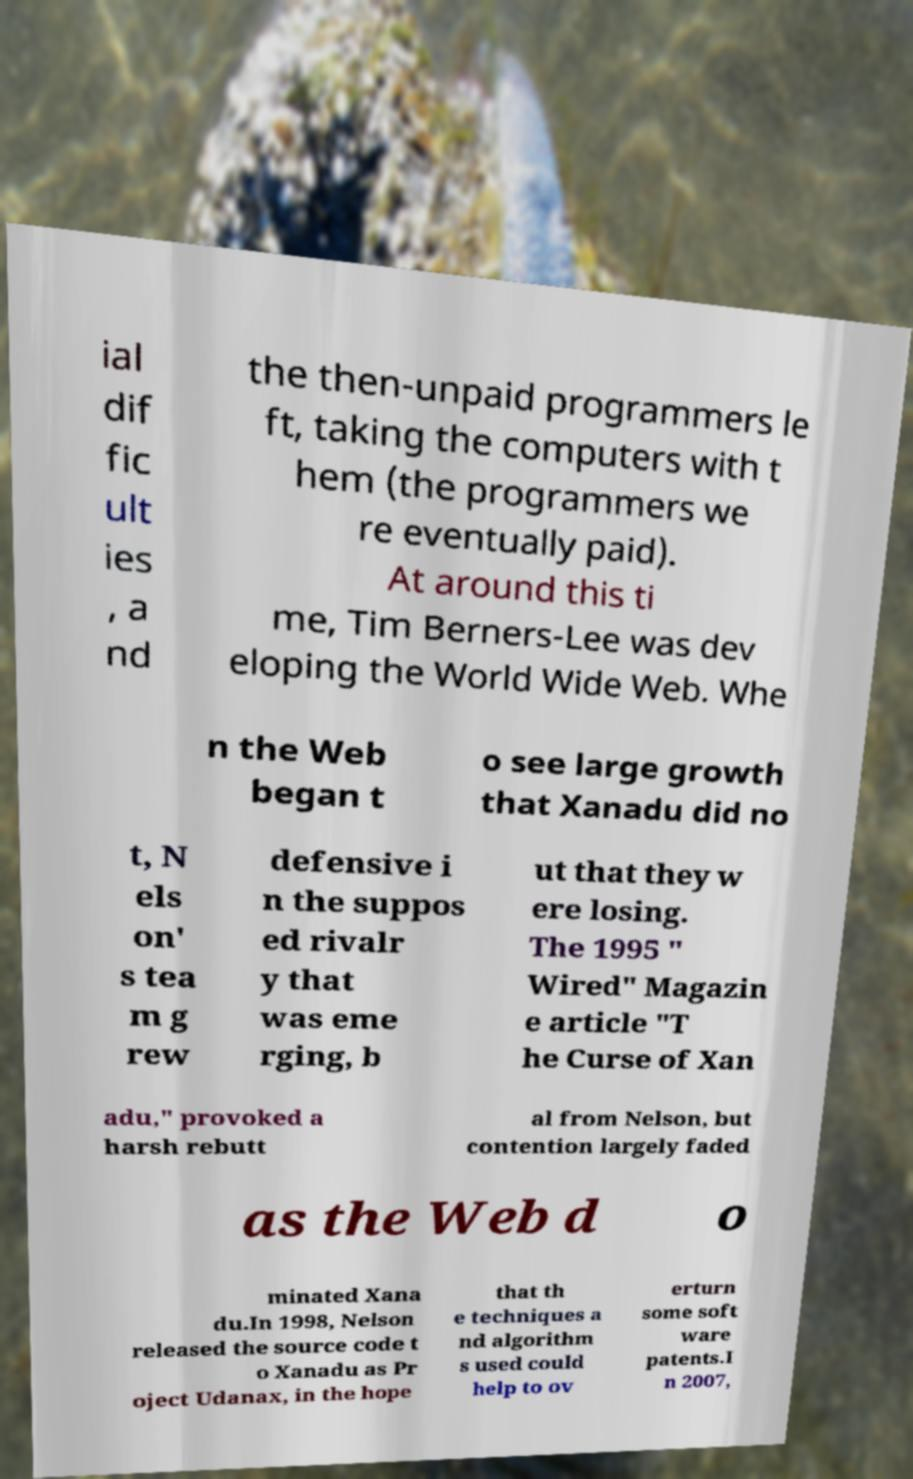Could you extract and type out the text from this image? ial dif fic ult ies , a nd the then-unpaid programmers le ft, taking the computers with t hem (the programmers we re eventually paid). At around this ti me, Tim Berners-Lee was dev eloping the World Wide Web. Whe n the Web began t o see large growth that Xanadu did no t, N els on' s tea m g rew defensive i n the suppos ed rivalr y that was eme rging, b ut that they w ere losing. The 1995 " Wired" Magazin e article "T he Curse of Xan adu," provoked a harsh rebutt al from Nelson, but contention largely faded as the Web d o minated Xana du.In 1998, Nelson released the source code t o Xanadu as Pr oject Udanax, in the hope that th e techniques a nd algorithm s used could help to ov erturn some soft ware patents.I n 2007, 